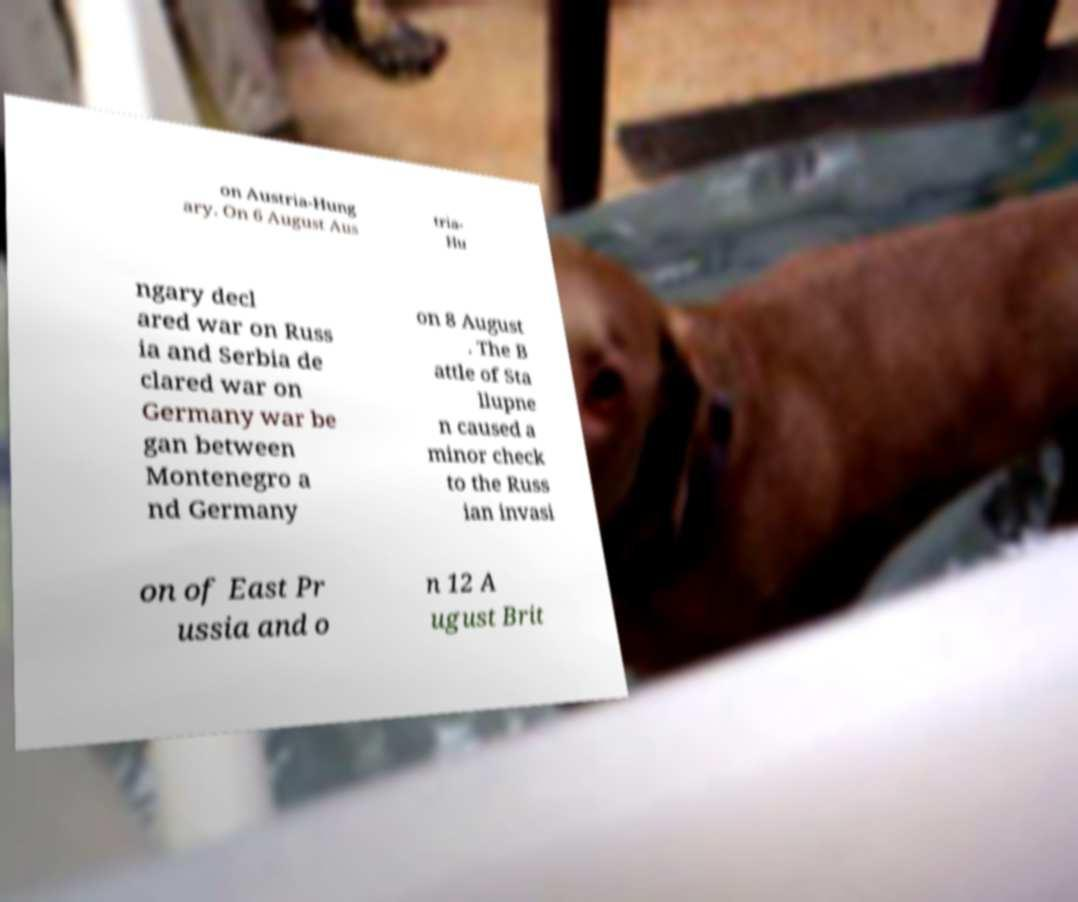Can you read and provide the text displayed in the image?This photo seems to have some interesting text. Can you extract and type it out for me? on Austria-Hung ary. On 6 August Aus tria- Hu ngary decl ared war on Russ ia and Serbia de clared war on Germany war be gan between Montenegro a nd Germany on 8 August . The B attle of Sta llupne n caused a minor check to the Russ ian invasi on of East Pr ussia and o n 12 A ugust Brit 